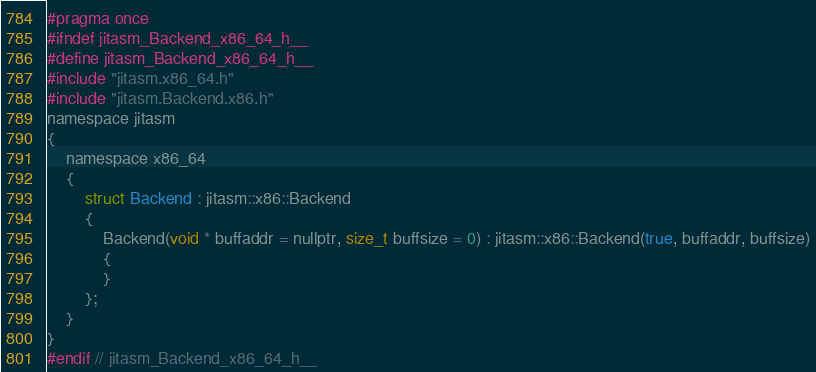Convert code to text. <code><loc_0><loc_0><loc_500><loc_500><_C_>#pragma once
#ifndef jitasm_Backend_x86_64_h__
#define jitasm_Backend_x86_64_h__
#include "jitasm.x86_64.h"
#include "jitasm.Backend.x86.h"
namespace jitasm
{
    namespace x86_64
    {
        struct Backend : jitasm::x86::Backend
        {
            Backend(void * buffaddr = nullptr, size_t buffsize = 0) : jitasm::x86::Backend(true, buffaddr, buffsize)
            {
            }
        };
    }
}
#endif // jitasm_Backend_x86_64_h__</code> 